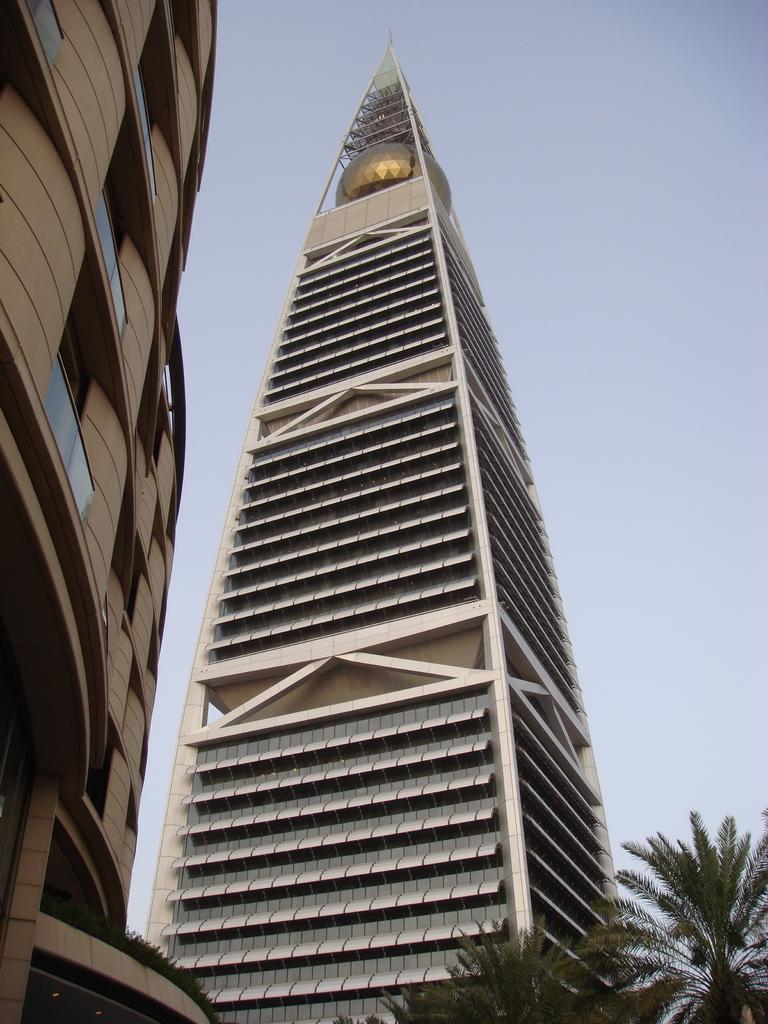What type of structure is the main subject of the image? There is a skyscraper in the image. Can you describe any other buildings in the image? There is a building with windows in the image. What type of natural elements can be seen in the image? There are trees in the image. What is visible in the background of the image? The sky is visible in the image. What flavor of ice cream is being served on the beds in the image? There are no beds or ice cream present in the image. 